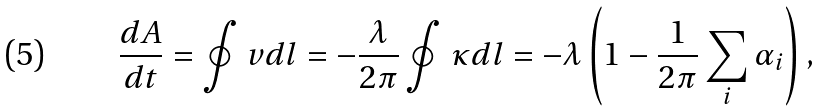Convert formula to latex. <formula><loc_0><loc_0><loc_500><loc_500>\frac { d A } { d t } = \oint v d l = - \frac { \lambda } { 2 \pi } \oint \kappa d l = - \lambda \left ( 1 - \frac { 1 } { 2 \pi } \sum _ { i } \alpha _ { i } \right ) ,</formula> 